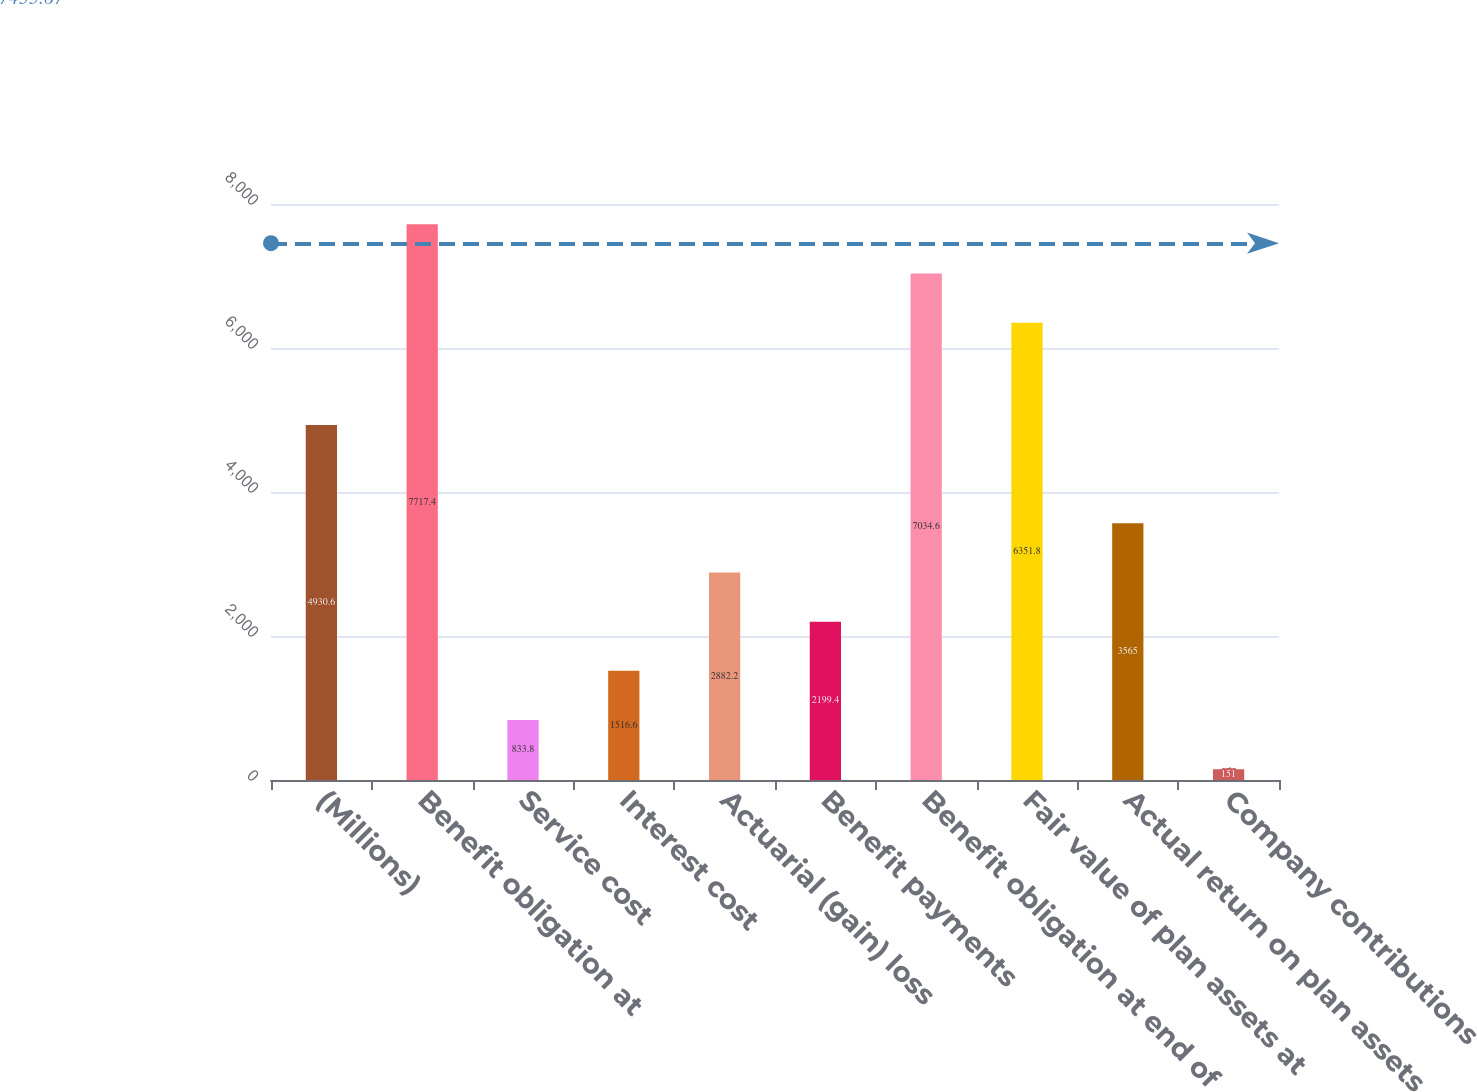Convert chart. <chart><loc_0><loc_0><loc_500><loc_500><bar_chart><fcel>(Millions)<fcel>Benefit obligation at<fcel>Service cost<fcel>Interest cost<fcel>Actuarial (gain) loss<fcel>Benefit payments<fcel>Benefit obligation at end of<fcel>Fair value of plan assets at<fcel>Actual return on plan assets<fcel>Company contributions<nl><fcel>4930.6<fcel>7717.4<fcel>833.8<fcel>1516.6<fcel>2882.2<fcel>2199.4<fcel>7034.6<fcel>6351.8<fcel>3565<fcel>151<nl></chart> 